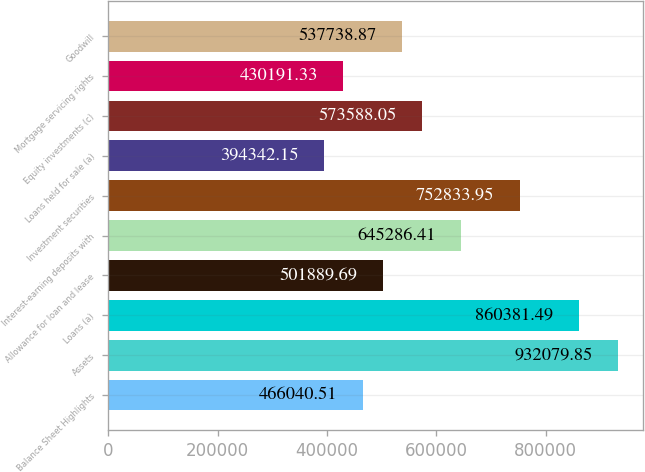<chart> <loc_0><loc_0><loc_500><loc_500><bar_chart><fcel>Balance Sheet Highlights<fcel>Assets<fcel>Loans (a)<fcel>Allowance for loan and lease<fcel>Interest-earning deposits with<fcel>Investment securities<fcel>Loans held for sale (a)<fcel>Equity investments (c)<fcel>Mortgage servicing rights<fcel>Goodwill<nl><fcel>466041<fcel>932080<fcel>860381<fcel>501890<fcel>645286<fcel>752834<fcel>394342<fcel>573588<fcel>430191<fcel>537739<nl></chart> 